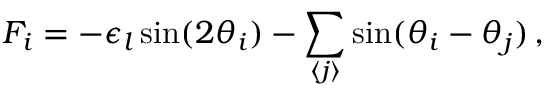Convert formula to latex. <formula><loc_0><loc_0><loc_500><loc_500>F _ { i } = - \epsilon _ { l } \sin ( 2 \theta _ { i } ) - \sum _ { \langle j \rangle } \sin ( \theta _ { i } - \theta _ { j } ) \, ,</formula> 